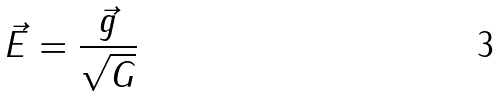Convert formula to latex. <formula><loc_0><loc_0><loc_500><loc_500>\vec { E } = \frac { \vec { g } } { \sqrt { G } }</formula> 